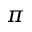Convert formula to latex. <formula><loc_0><loc_0><loc_500><loc_500>\pi</formula> 